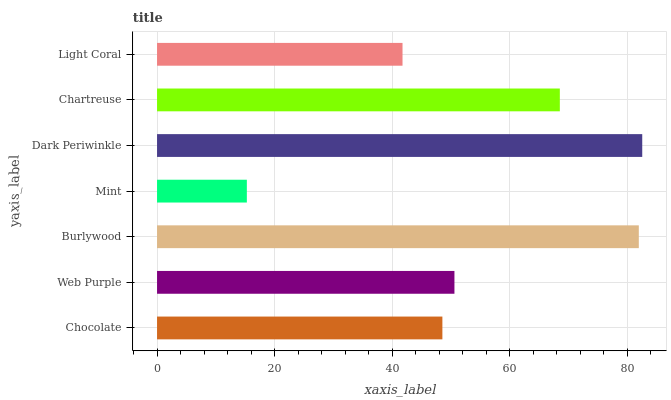Is Mint the minimum?
Answer yes or no. Yes. Is Dark Periwinkle the maximum?
Answer yes or no. Yes. Is Web Purple the minimum?
Answer yes or no. No. Is Web Purple the maximum?
Answer yes or no. No. Is Web Purple greater than Chocolate?
Answer yes or no. Yes. Is Chocolate less than Web Purple?
Answer yes or no. Yes. Is Chocolate greater than Web Purple?
Answer yes or no. No. Is Web Purple less than Chocolate?
Answer yes or no. No. Is Web Purple the high median?
Answer yes or no. Yes. Is Web Purple the low median?
Answer yes or no. Yes. Is Light Coral the high median?
Answer yes or no. No. Is Light Coral the low median?
Answer yes or no. No. 